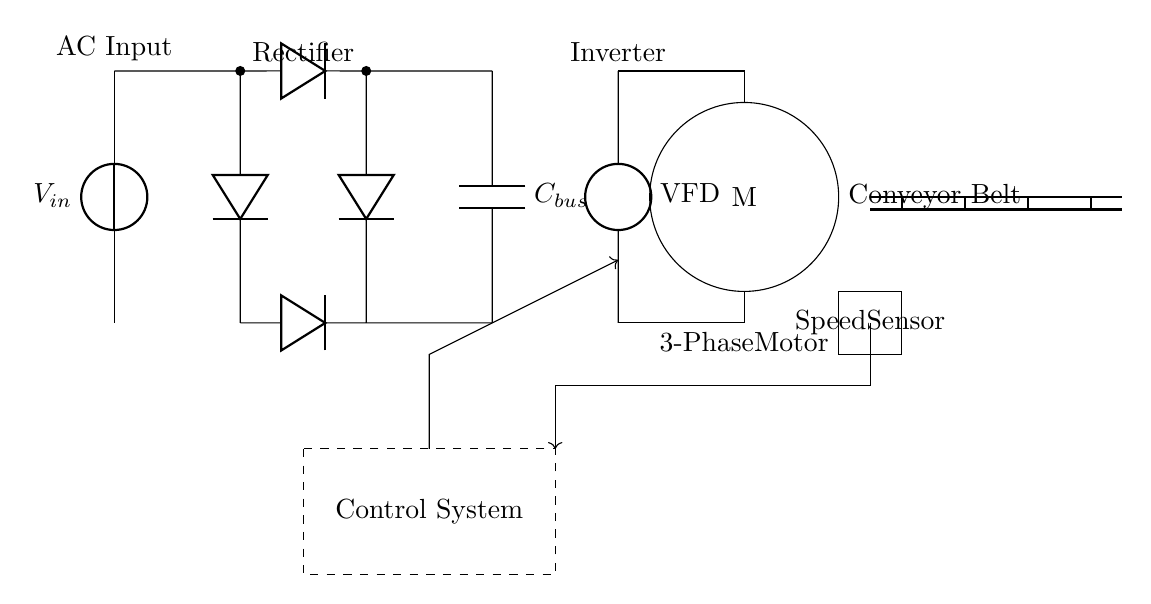What type of motor is used in this circuit? The circuit diagram specifies that a three-phase motor is present, indicated by the label "3-Phase Motor" connected to the inverter.
Answer: Three-phase motor What component converts AC to DC? In the circuit, the rectifier is responsible for converting alternating current (AC) to direct current (DC), as represented by the block and labeled accordingly.
Answer: Rectifier What is the role of the capacitor in the circuit? The capacitor, labeled "C bus," functions as a DC bus capacitor, which stabilizes the voltage and stores energy, smoothing the output from the rectifier before feeding into the inverter.
Answer: Stabilizes voltage What device controls the motor speed? The control system, indicated by the dashed rectangle, oversees the operation of the circuit, including adjusting the speed of the motor based on the input from the speed sensor.
Answer: Control System How does the speed sensor communicate with the control system? The speed sensor sends feedback to the control system via a directional arrow indicating the flow of information, showing how the speed measurement impacts motor control.
Answer: By feedback signal What type of input does the circuit accept? The circuit receives an AC input voltage, as indicated by the label "AC Input" at the beginning of the circuit, which starts the power conversion process.
Answer: AC Input 